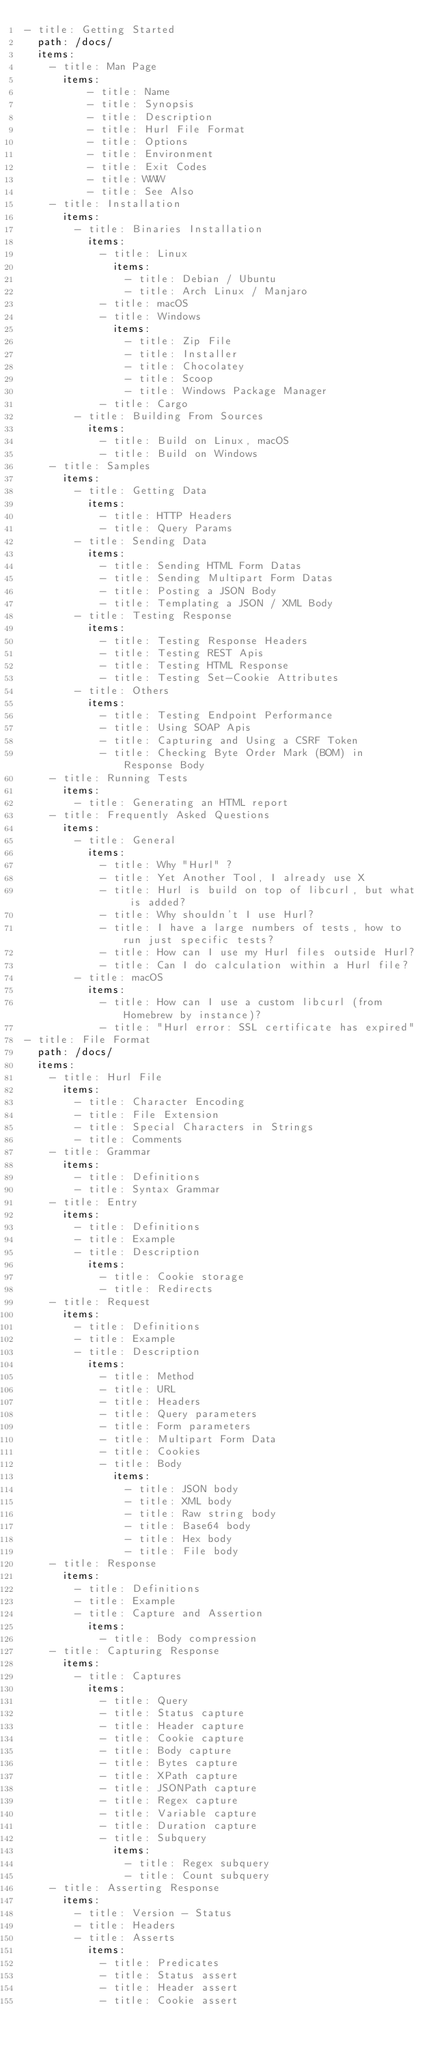Convert code to text. <code><loc_0><loc_0><loc_500><loc_500><_YAML_>- title: Getting Started
  path: /docs/
  items:
    - title: Man Page
      items:
          - title: Name
          - title: Synopsis
          - title: Description
          - title: Hurl File Format
          - title: Options
          - title: Environment
          - title: Exit Codes
          - title: WWW
          - title: See Also
    - title: Installation
      items:
        - title: Binaries Installation
          items:
            - title: Linux
              items:
                - title: Debian / Ubuntu
                - title: Arch Linux / Manjaro
            - title: macOS
            - title: Windows
              items:
                - title: Zip File
                - title: Installer
                - title: Chocolatey
                - title: Scoop
                - title: Windows Package Manager
            - title: Cargo
        - title: Building From Sources
          items:
            - title: Build on Linux, macOS
            - title: Build on Windows
    - title: Samples
      items:
        - title: Getting Data
          items:
            - title: HTTP Headers
            - title: Query Params
        - title: Sending Data
          items:
            - title: Sending HTML Form Datas
            - title: Sending Multipart Form Datas
            - title: Posting a JSON Body
            - title: Templating a JSON / XML Body
        - title: Testing Response
          items:
            - title: Testing Response Headers
            - title: Testing REST Apis
            - title: Testing HTML Response
            - title: Testing Set-Cookie Attributes
        - title: Others
          items:
            - title: Testing Endpoint Performance
            - title: Using SOAP Apis
            - title: Capturing and Using a CSRF Token
            - title: Checking Byte Order Mark (BOM) in Response Body
    - title: Running Tests
      items:
        - title: Generating an HTML report
    - title: Frequently Asked Questions
      items:
        - title: General
          items:
            - title: Why "Hurl" ?
            - title: Yet Another Tool, I already use X
            - title: Hurl is build on top of libcurl, but what is added?
            - title: Why shouldn't I use Hurl?
            - title: I have a large numbers of tests, how to run just specific tests?
            - title: How can I use my Hurl files outside Hurl?
            - title: Can I do calculation within a Hurl file?
        - title: macOS
          items:
            - title: How can I use a custom libcurl (from Homebrew by instance)?
            - title: "Hurl error: SSL certificate has expired"
- title: File Format
  path: /docs/
  items:
    - title: Hurl File
      items:
        - title: Character Encoding
        - title: File Extension
        - title: Special Characters in Strings
        - title: Comments
    - title: Grammar
      items:
        - title: Definitions
        - title: Syntax Grammar
    - title: Entry
      items:
        - title: Definitions
        - title: Example
        - title: Description
          items:
            - title: Cookie storage
            - title: Redirects
    - title: Request
      items:
        - title: Definitions
        - title: Example
        - title: Description
          items:
            - title: Method
            - title: URL
            - title: Headers
            - title: Query parameters
            - title: Form parameters
            - title: Multipart Form Data
            - title: Cookies
            - title: Body
              items:
                - title: JSON body
                - title: XML body
                - title: Raw string body
                - title: Base64 body
                - title: Hex body
                - title: File body
    - title: Response
      items:
        - title: Definitions
        - title: Example
        - title: Capture and Assertion
          items:
            - title: Body compression
    - title: Capturing Response
      items:
        - title: Captures
          items:
            - title: Query
            - title: Status capture
            - title: Header capture
            - title: Cookie capture
            - title: Body capture
            - title: Bytes capture
            - title: XPath capture
            - title: JSONPath capture
            - title: Regex capture
            - title: Variable capture
            - title: Duration capture
            - title: Subquery
              items:
                - title: Regex subquery
                - title: Count subquery
    - title: Asserting Response
      items:
        - title: Version - Status
        - title: Headers
        - title: Asserts
          items:
            - title: Predicates
            - title: Status assert
            - title: Header assert
            - title: Cookie assert</code> 